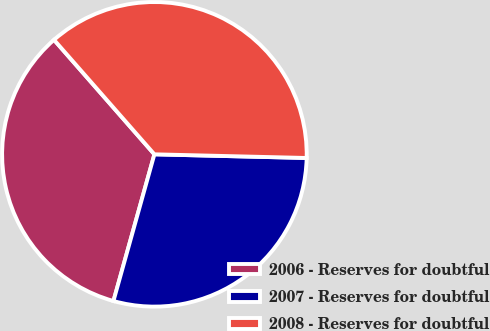<chart> <loc_0><loc_0><loc_500><loc_500><pie_chart><fcel>2006 - Reserves for doubtful<fcel>2007 - Reserves for doubtful<fcel>2008 - Reserves for doubtful<nl><fcel>34.21%<fcel>28.95%<fcel>36.84%<nl></chart> 